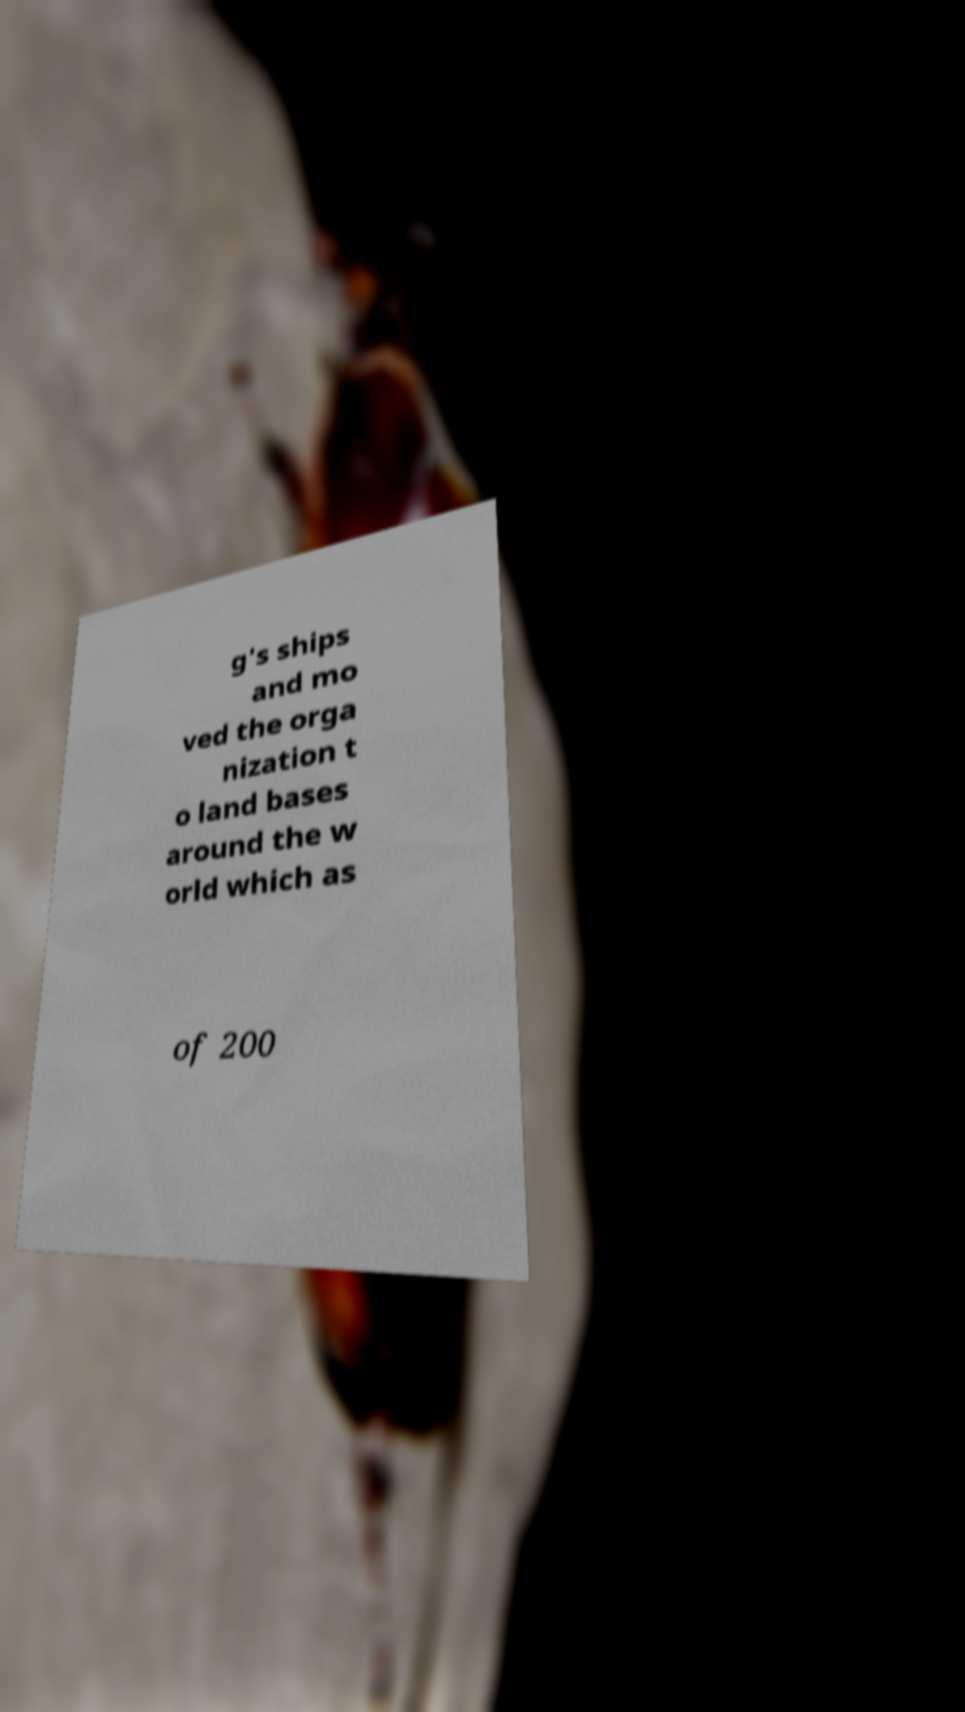Could you assist in decoding the text presented in this image and type it out clearly? g's ships and mo ved the orga nization t o land bases around the w orld which as of 200 